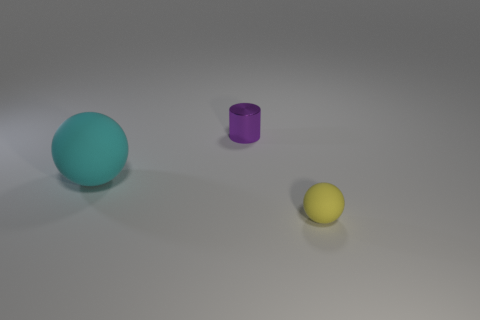Is there anything else that is the same shape as the metallic object?
Your answer should be compact. No. There is a object that is in front of the cylinder and on the right side of the big cyan matte ball; what material is it?
Offer a terse response. Rubber. What material is the yellow object that is the same shape as the big cyan thing?
Make the answer very short. Rubber. What number of big objects are left of the ball left of the object that is to the right of the cylinder?
Give a very brief answer. 0. Is there anything else that is the same color as the tiny metallic thing?
Your answer should be very brief. No. How many things are both in front of the metal cylinder and to the left of the tiny yellow rubber thing?
Make the answer very short. 1. There is a object on the left side of the tiny purple metal thing; is its size the same as the ball that is on the right side of the cylinder?
Give a very brief answer. No. How many things are matte balls that are left of the small purple shiny object or large brown cylinders?
Offer a very short reply. 1. What is the sphere that is behind the small yellow matte ball made of?
Offer a terse response. Rubber. What is the yellow ball made of?
Ensure brevity in your answer.  Rubber. 